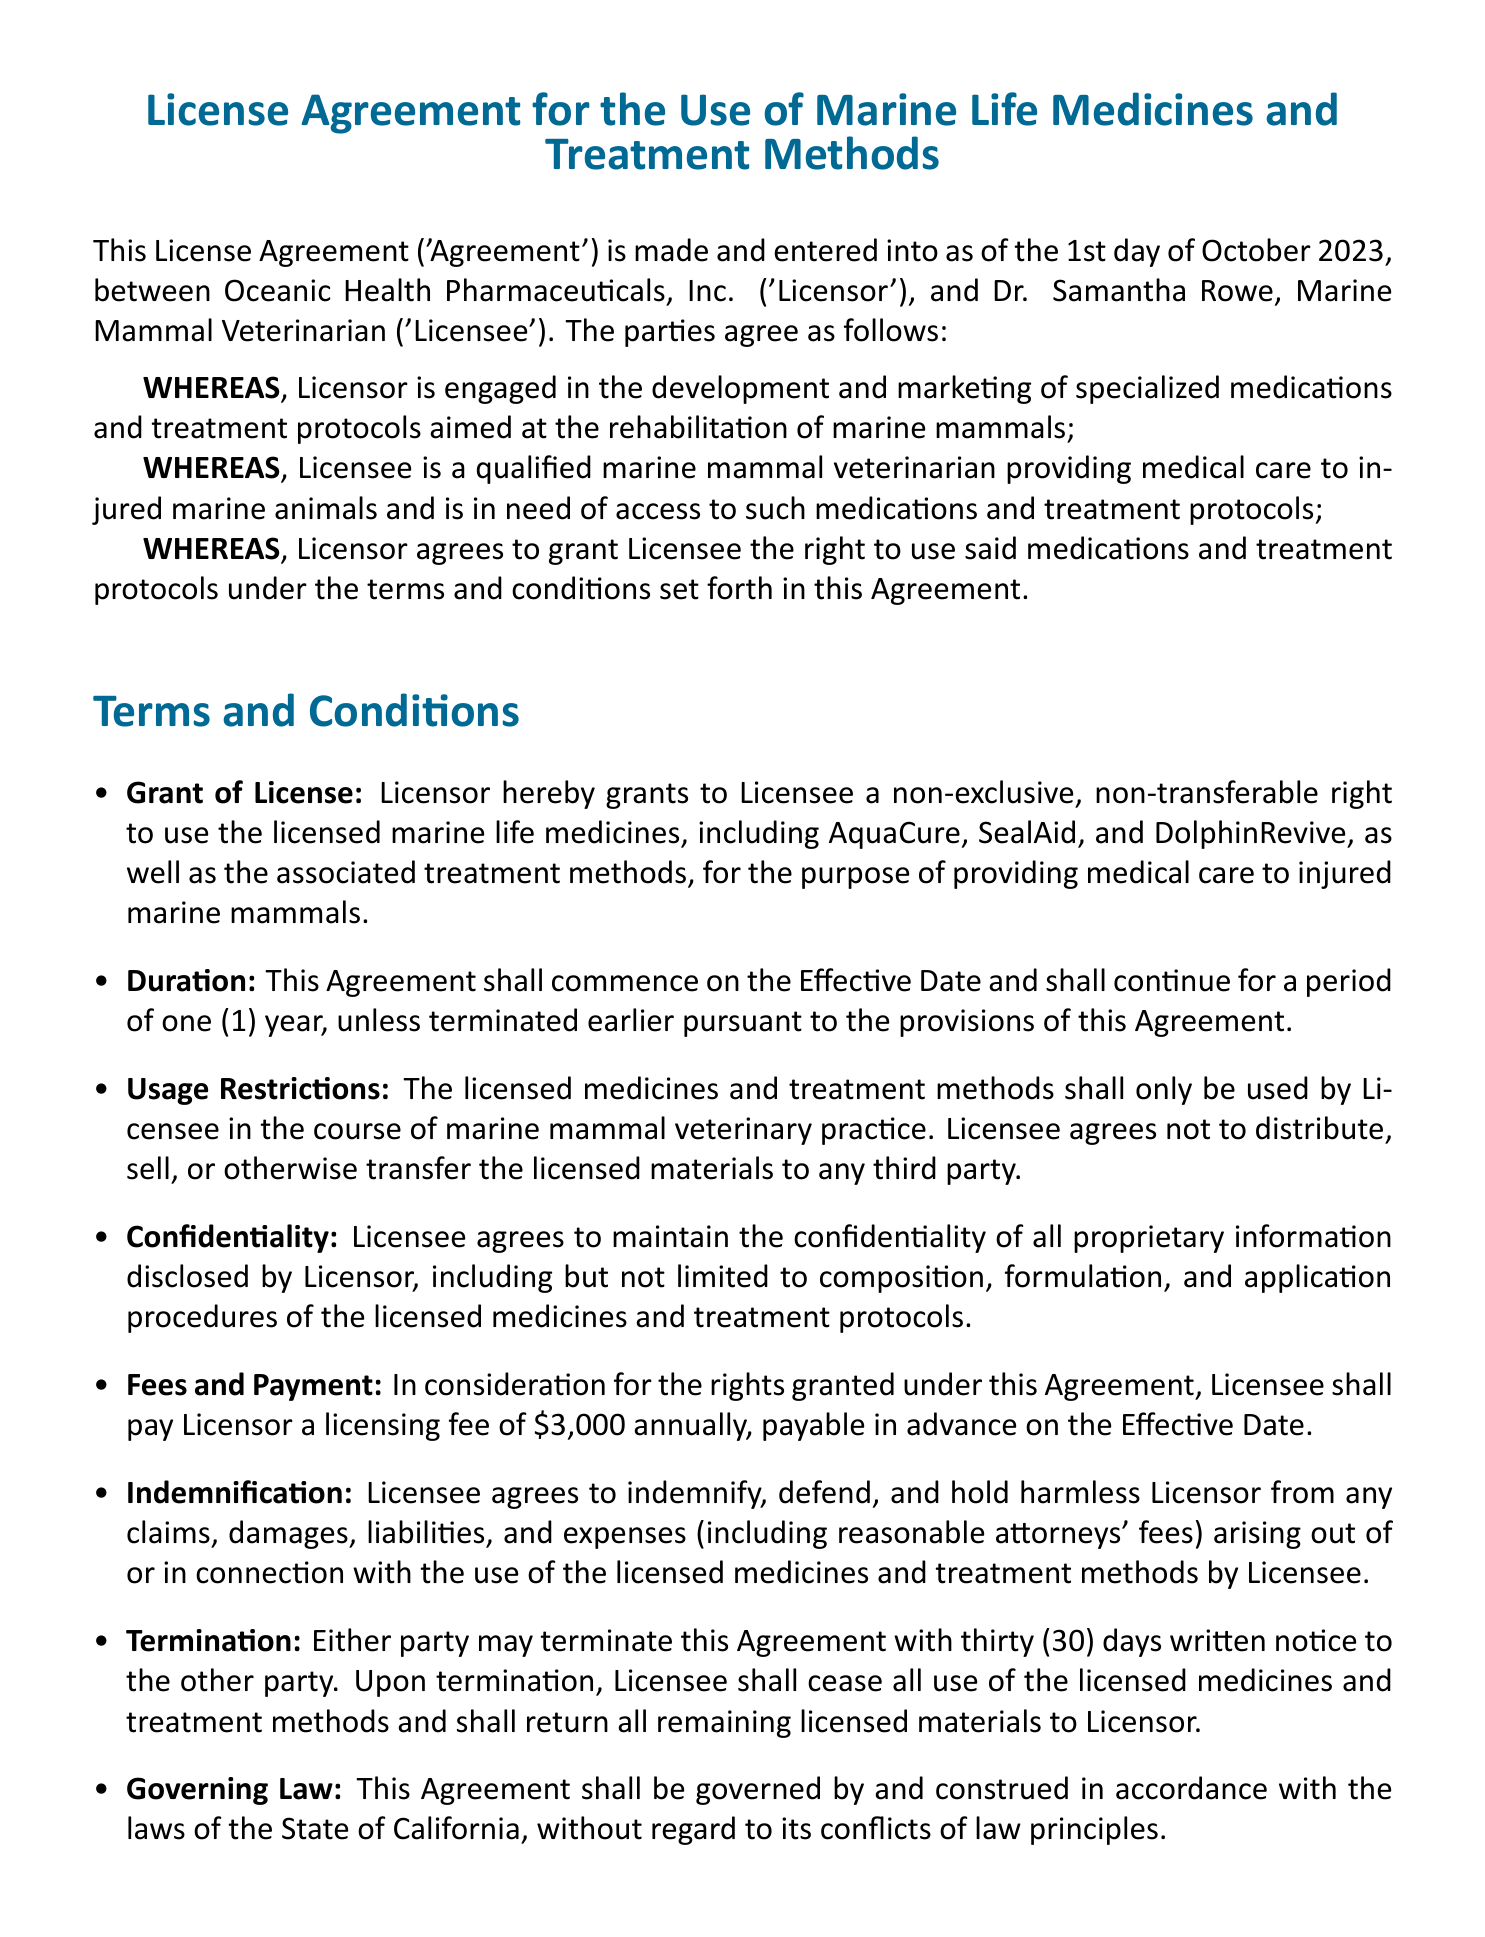What is the effective date of the agreement? The effective date is mentioned at the beginning of the document.
Answer: 1st day of October 2023 Who is the Licensee? The Licensee is stated in the introduction of the agreement.
Answer: Dr. Samantha Rowe What is the licensing fee amount? The fee is specified in the "Fees and Payment" section of the agreement.
Answer: $3,000 How long is the duration of the agreement? The duration is detailed in the "Duration" section of the agreement.
Answer: one (1) year What must the Licensee do upon termination? This is stated in the "Termination" section of the agreement.
Answer: Cease all use of the licensed medicines What are the licensed medicines mentioned? The licensed medicines are listed in the "Grant of License" section.
Answer: AquaCure, SealAid, DolphinRevive Which state governs the agreement? The governing law is indicated at the end of the document.
Answer: California What type of license is granted to the Licensee? The type of license granted is described in the "Grant of License" section.
Answer: non-exclusive, non-transferable 